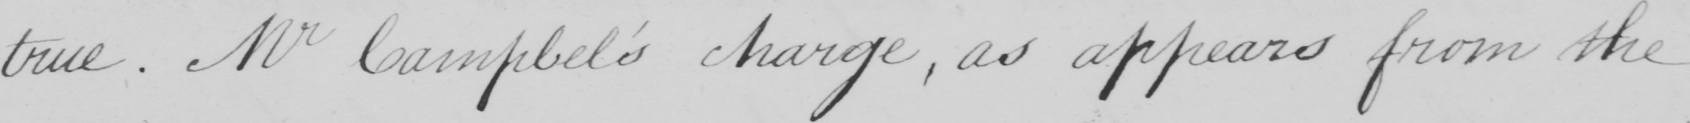What text is written in this handwritten line? true  . Mr Campbel ' s charge , as appears from the 